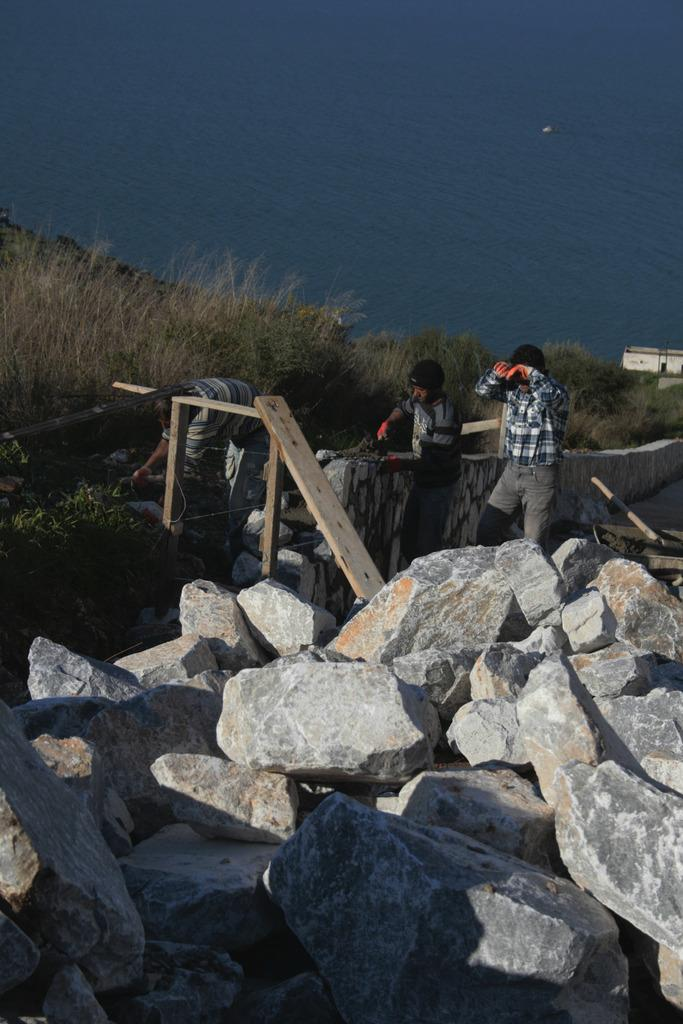What is at the bottom of the image? There are rocks at the bottom of the image. How many men are present in the image? There are three men behind the rocks. What is the background of the image? There is a wall in the image. What type of vegetation is present in the image? There is grass on the ground. What can be seen in the distance in the image? There is water visible at the top of the image. What type of ball is being used by the men in the image? There is no ball present in the image; the men are behind rocks. What detail can be seen on the wall in the image? There is no specific detail mentioned in the facts, so we cannot determine any details on the wall. 